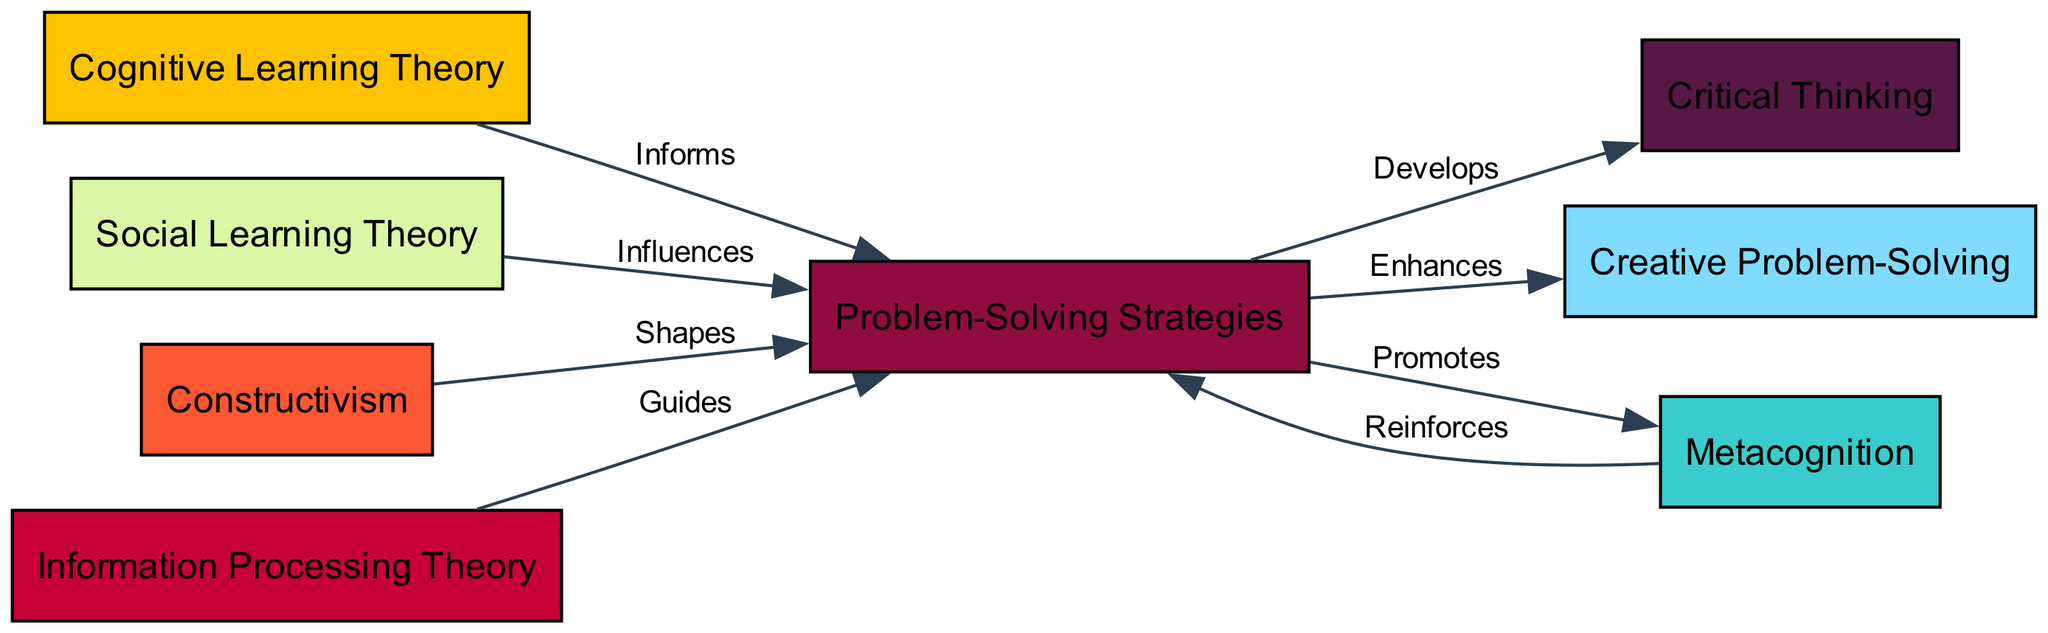What is the total number of nodes in the diagram? The diagram includes defined nodes, each representing a different psychological theory or application related to problem-solving. By counting the nodes listed in the provided data, we find there are eight distinct nodes.
Answer: 8 Which theory influences Problem-Solving Strategies? The diagram shows edges connecting various theories to the Problem-Solving Strategies node. Specifically, Social Learning Theory is noted to influence this strategy as indicated by the directed edge labeled "Influences".
Answer: Social Learning Theory What are the two nodes that result from the Problem-Solving Strategies node? The edges leading from Problem-Solving Strategies indicate its resulting applications. Two nodes connect directly as a result: Critical Thinking (Develops) and Creative Problem-Solving (Enhances).
Answer: Critical Thinking and Creative Problem-Solving How many edges are there in the diagram? Each edge signifies a connection between nodes, illustrating the interrelationships. Counting the edges in the provided data shows there are a total of seven edges connecting the nodes.
Answer: 7 What role does Metacognition play in relation to Problem-Solving Strategies? The diagram indicates a bidirectional relationship with Metacognition. It promotes Problem-Solving Strategies, as well as being reinforced by these strategies, establishing a reciprocal influence.
Answer: Promotes and Reinforces Which theory shapes the Problem-Solving Strategies? The edge labeled "Shapes" connects the Constructivism node to Problem-Solving Strategies, indicating that Constructivism plays a role in shaping these strategies.
Answer: Constructivism What is the relationship between Information Processing Theory and Problem-Solving Strategies? The edge between Information Processing Theory and Problem-Solving Strategies is labeled "Guides", suggesting that Information Processing Theory has a guiding effect on the application of problem-solving strategies.
Answer: Guides Out of all the edges, which one indicates a reinforcement relationship? The edge from Metacognition to Problem-Solving Strategies is labeled "Reinforces", indicating a reinforcing relationship as opposed to an influencing or guiding one.
Answer: Reinforces Which nodes are directly connected to Critical Thinking? The Problem-Solving Strategies node is connected to Critical Thinking through the edge labeled "Develops", indicating that Critical Thinking is a direct application stemming from problem-solving methodologies.
Answer: Problem-Solving Strategies 